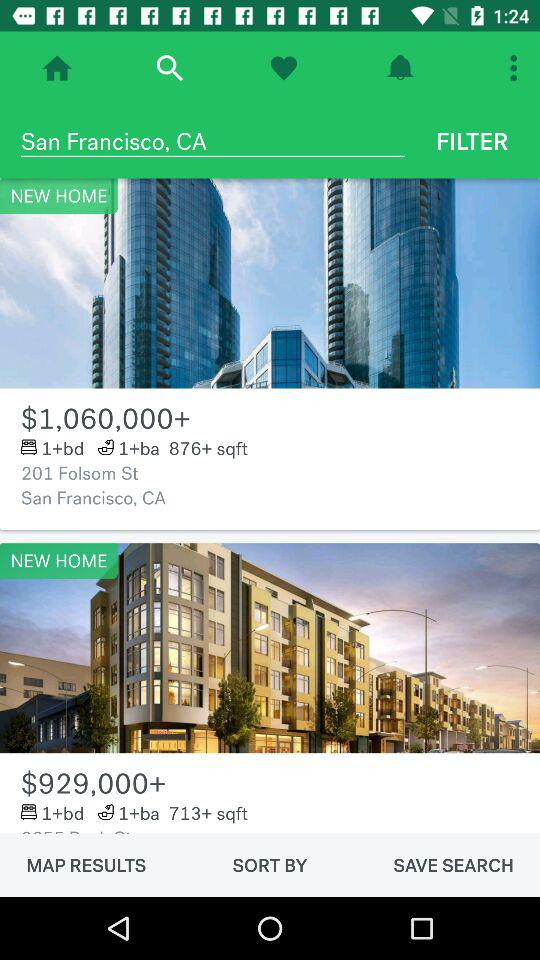What is the cost of a 1-bedroom, 1-bathroom, 713-square-foot home? The cost of a 1-bedroom, 1-bathroom, 713-square-foot home is $929,000+. 